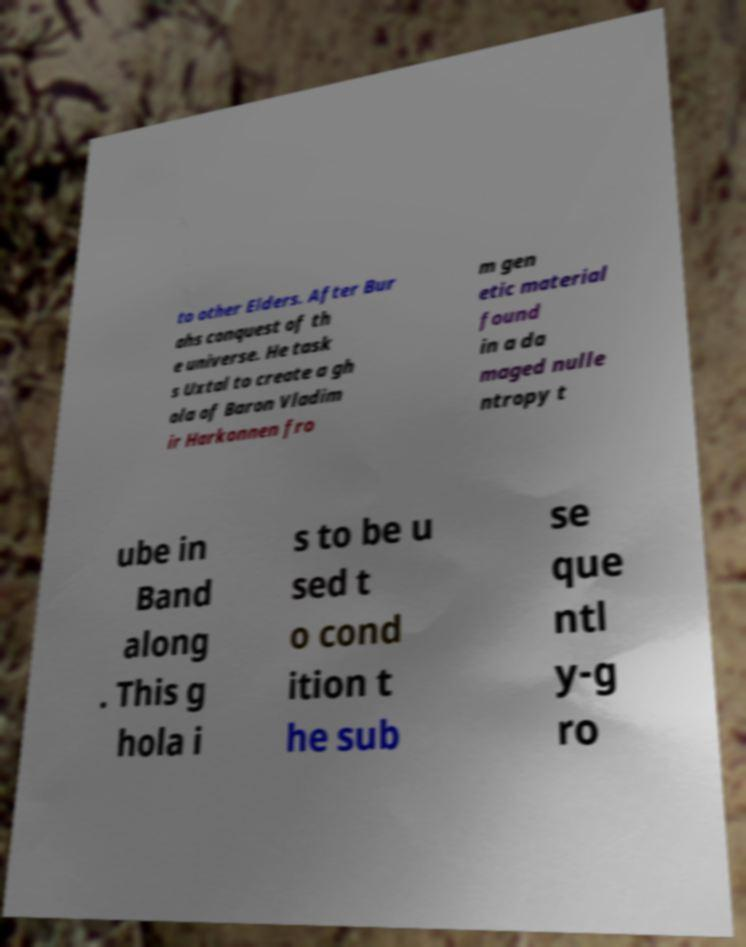There's text embedded in this image that I need extracted. Can you transcribe it verbatim? to other Elders. After Bur ahs conquest of th e universe. He task s Uxtal to create a gh ola of Baron Vladim ir Harkonnen fro m gen etic material found in a da maged nulle ntropy t ube in Band along . This g hola i s to be u sed t o cond ition t he sub se que ntl y-g ro 